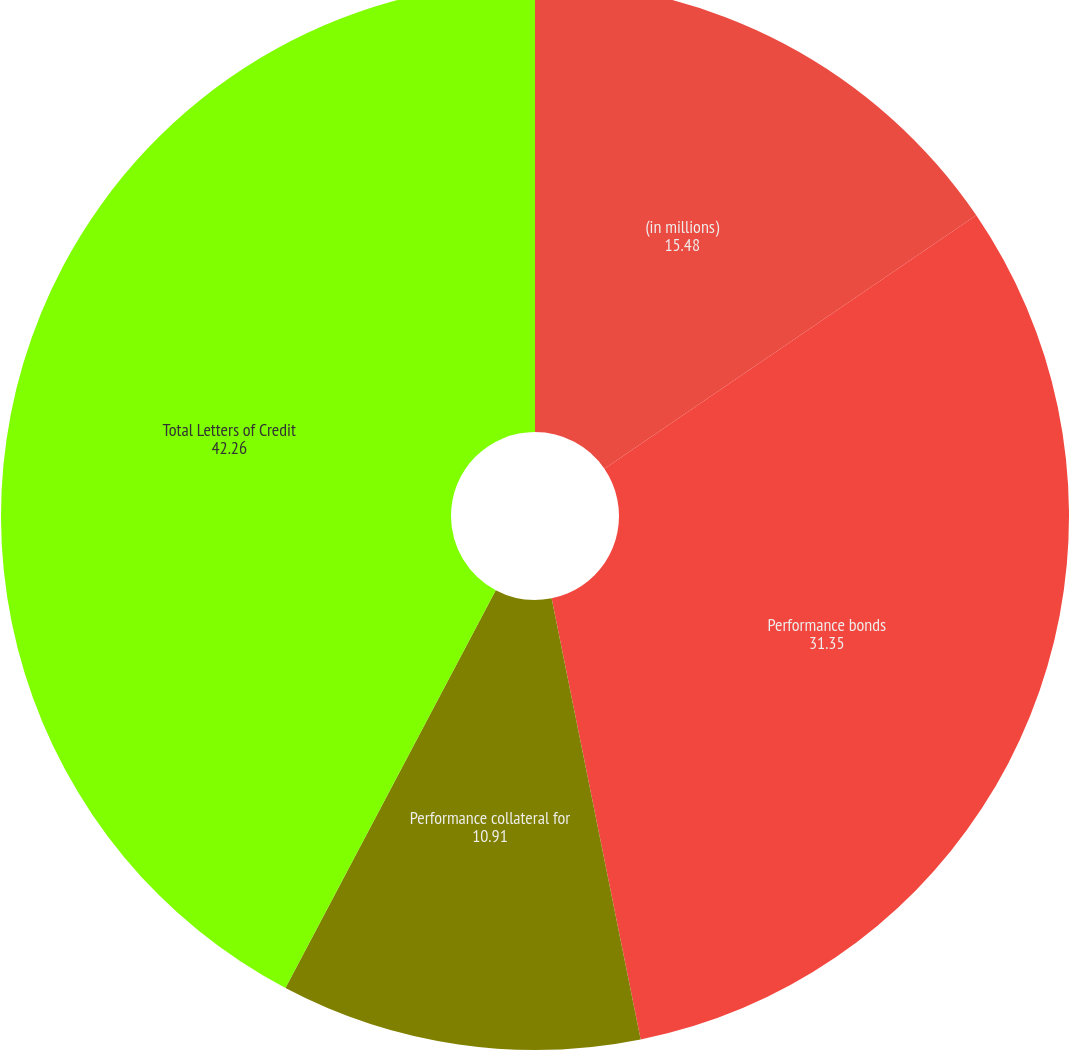<chart> <loc_0><loc_0><loc_500><loc_500><pie_chart><fcel>(in millions)<fcel>Performance bonds<fcel>Performance collateral for<fcel>Total Letters of Credit<nl><fcel>15.48%<fcel>31.35%<fcel>10.91%<fcel>42.26%<nl></chart> 